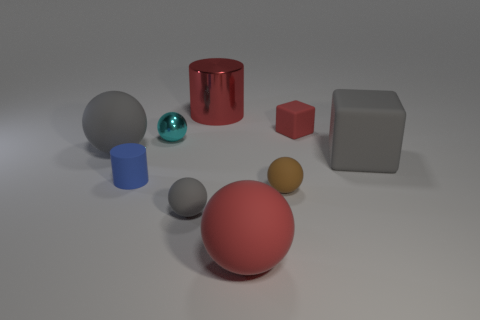Add 1 red shiny things. How many objects exist? 10 Subtract all cyan spheres. How many spheres are left? 4 Add 9 cyan metal objects. How many cyan metal objects are left? 10 Add 4 red spheres. How many red spheres exist? 5 Subtract all red balls. How many balls are left? 4 Subtract 0 green spheres. How many objects are left? 9 Subtract all spheres. How many objects are left? 4 Subtract 3 balls. How many balls are left? 2 Subtract all cyan balls. Subtract all purple cylinders. How many balls are left? 4 Subtract all purple blocks. How many red spheres are left? 1 